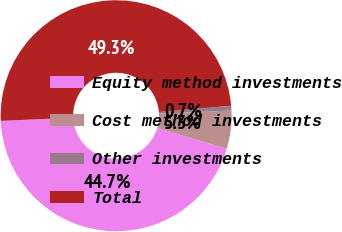<chart> <loc_0><loc_0><loc_500><loc_500><pie_chart><fcel>Equity method investments<fcel>Cost method investments<fcel>Other investments<fcel>Total<nl><fcel>44.67%<fcel>5.33%<fcel>0.66%<fcel>49.34%<nl></chart> 